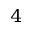Convert formula to latex. <formula><loc_0><loc_0><loc_500><loc_500>_ { 4 }</formula> 